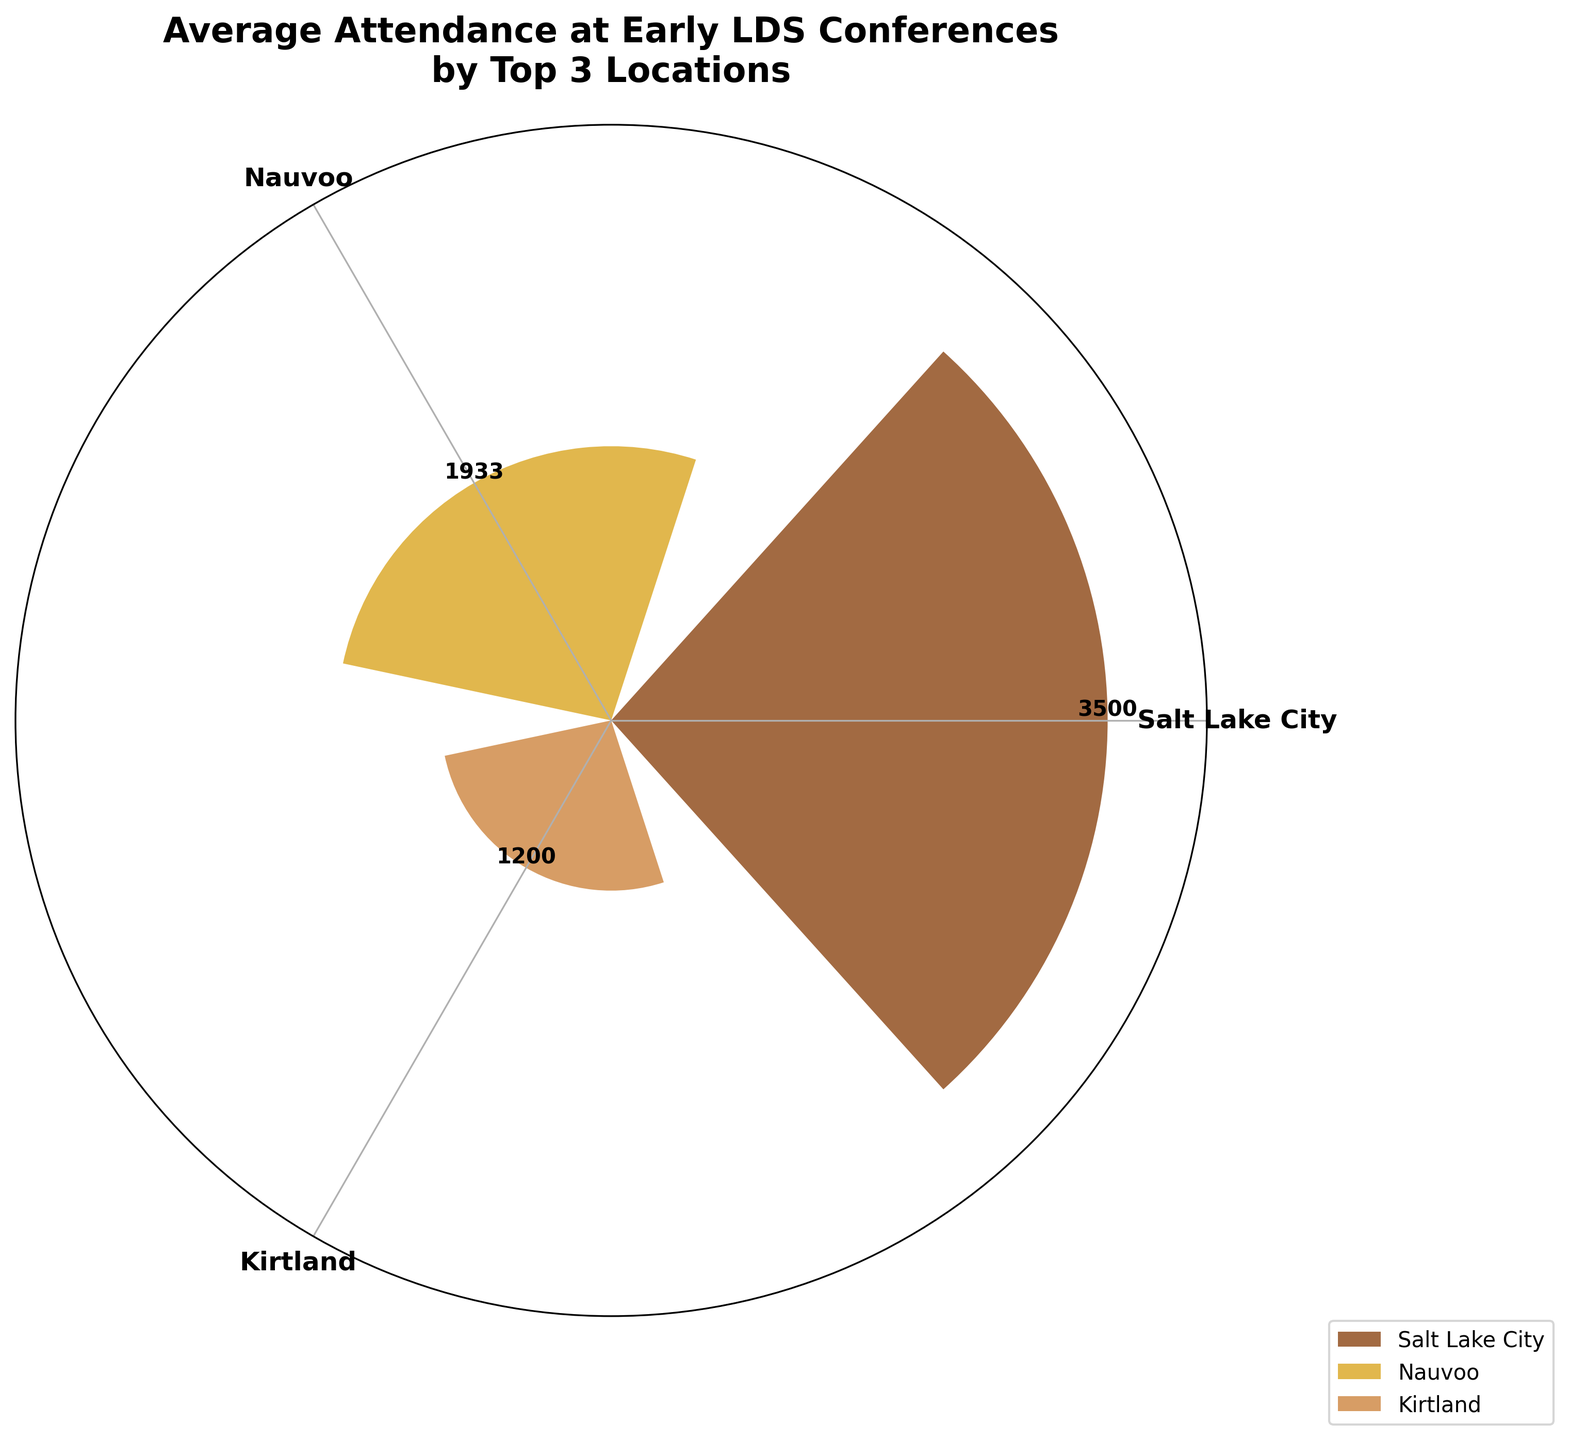What is the title of the figure? The title of the figure is displayed right at the top of the chart. It helps to understand what the figure is representing.
Answer: Average Attendance at Early LDS Conferences by Top 3 Locations Which locations are represented on the figure? The locations are typically represented by different segments in the rose chart and are labeled accordingly at each corresponding angle.
Answer: Nauvoo, Kirtland, Salt Lake City Which location has the highest average attendance at LDS conferences? From the lengths of the bars, the location with the highest average attendance will have the longest bar radius.
Answer: Salt Lake City What colors represent the locations, and which color corresponds to which location? The colors of the bars represent different locations and are often provided in a legend. By referring to the legend, we can determine the color-location mapping.
Answer: Nauvoo: Brown, Kirtland: Gold, Salt Lake City: Tan What is the average attendance at conferences in Nauvoo? The figure provides value labels for each bar segment. The value label on the segment representing Nauvoo gives the average attendance.
Answer: 1933 What is the difference in average attendance between Kirtland and Nauvoo? First identify the averages for both Nauvoo and Kirtland from their respective bars. Subtract the average of Kirtland from that of Nauvoo.
Answer: 733 How much higher is the average attendance in Salt Lake City compared to Kirtland? Identify the average attendance for Salt Lake City and Kirtland from the bars. Subtract the average for Kirtland from the average for Salt Lake City to determine how much higher it is.
Answer: 2100 How many main bars (data points) are displayed in the figure? Count the number of different bar segments since this represents the different data points (locations) shown in the rose chart.
Answer: 3 Which location has the smallest average attendance? The location with the smallest average attendance will have the shortest bar radius.
Answer: Kirtland Considering all the locations, what is the average of their average attendance? Add the average attendance values for Nauvoo, Kirtland, and Salt Lake City and then divide by the number of locations.
Answer: (1933 + 1200 + 3300) / 3 = 2144 